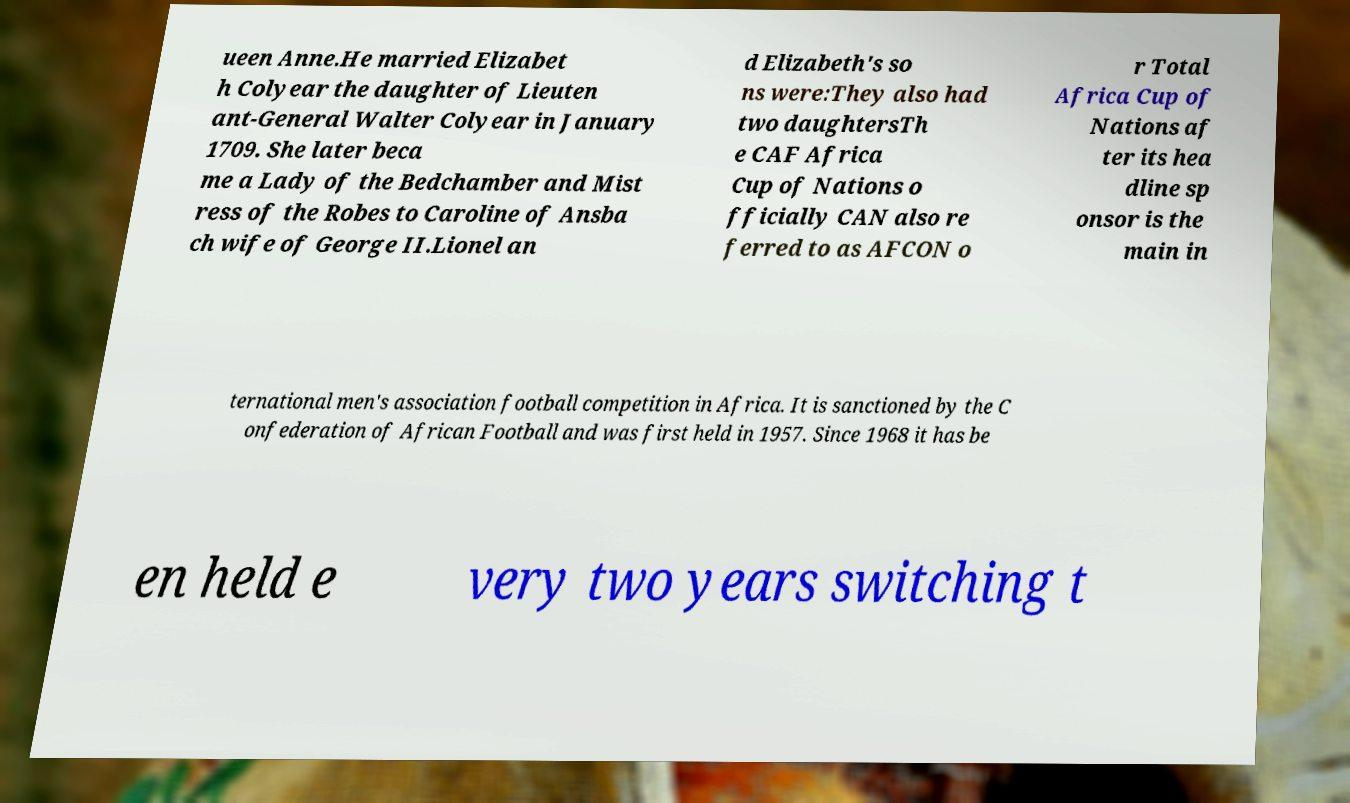Could you extract and type out the text from this image? ueen Anne.He married Elizabet h Colyear the daughter of Lieuten ant-General Walter Colyear in January 1709. She later beca me a Lady of the Bedchamber and Mist ress of the Robes to Caroline of Ansba ch wife of George II.Lionel an d Elizabeth's so ns were:They also had two daughtersTh e CAF Africa Cup of Nations o fficially CAN also re ferred to as AFCON o r Total Africa Cup of Nations af ter its hea dline sp onsor is the main in ternational men's association football competition in Africa. It is sanctioned by the C onfederation of African Football and was first held in 1957. Since 1968 it has be en held e very two years switching t 